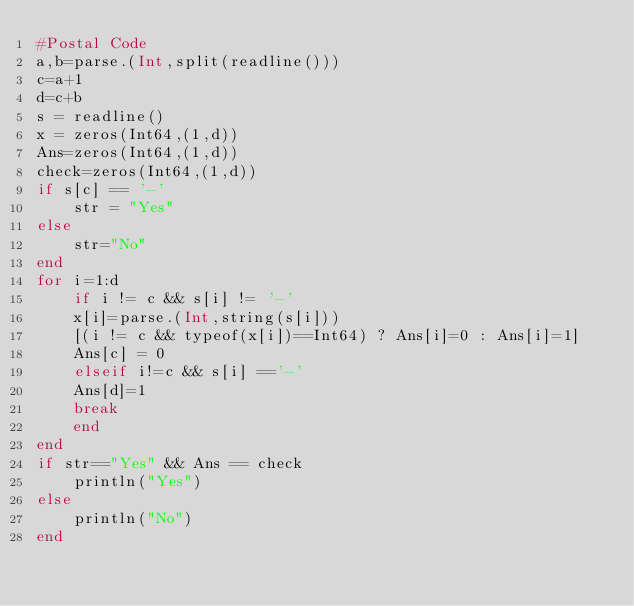Convert code to text. <code><loc_0><loc_0><loc_500><loc_500><_Julia_>#Postal Code
a,b=parse.(Int,split(readline()))
c=a+1
d=c+b
s = readline()
x = zeros(Int64,(1,d))
Ans=zeros(Int64,(1,d))
check=zeros(Int64,(1,d))
if s[c] == '-' 
    str = "Yes"
else 
    str="No"
end
for i=1:d
    if i != c && s[i] != '-' 
    x[i]=parse.(Int,string(s[i]))
    [(i != c && typeof(x[i])==Int64) ? Ans[i]=0 : Ans[i]=1] 
    Ans[c] = 0
    elseif i!=c && s[i] =='-' 
    Ans[d]=1
    break
    end
end
if str=="Yes" && Ans == check
    println("Yes")
else
    println("No")
end</code> 